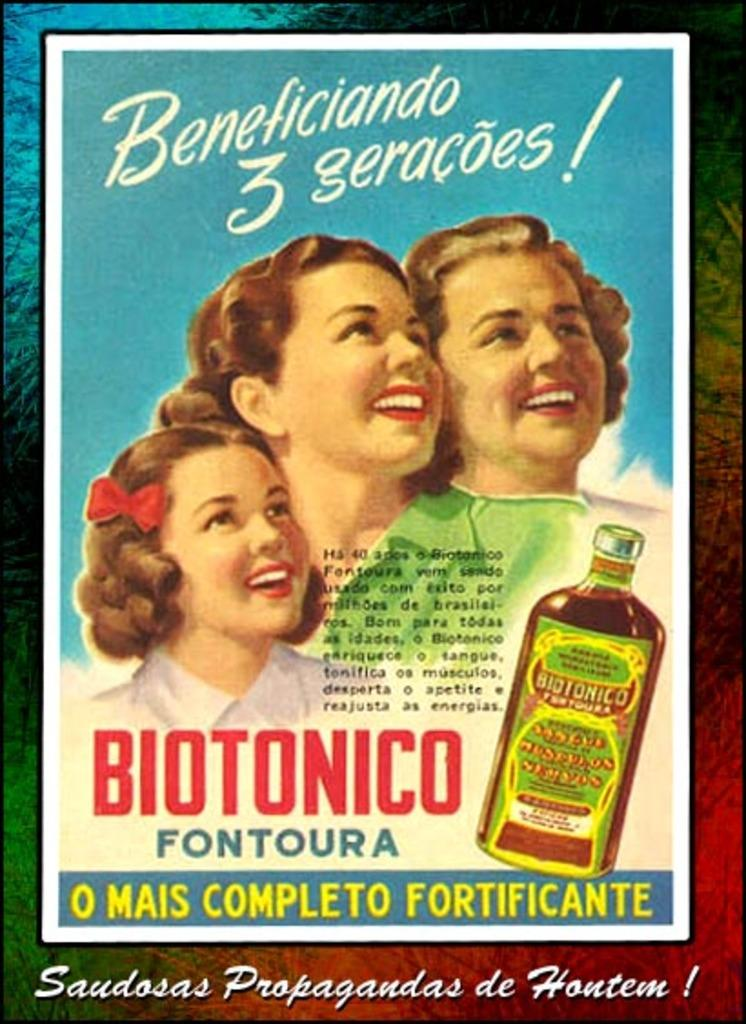<image>
Provide a brief description of the given image. An advertisement of Biotonico Fontoura with three girls. 